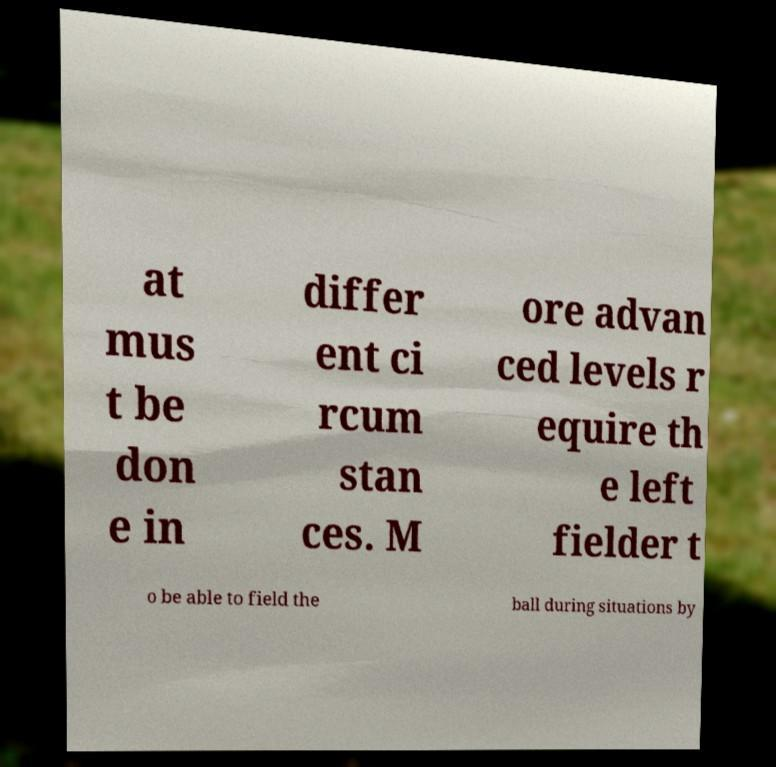There's text embedded in this image that I need extracted. Can you transcribe it verbatim? at mus t be don e in differ ent ci rcum stan ces. M ore advan ced levels r equire th e left fielder t o be able to field the ball during situations by 